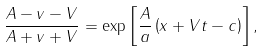Convert formula to latex. <formula><loc_0><loc_0><loc_500><loc_500>\frac { A - v - V } { A + v + V } = \exp \left [ \frac { A } { a } \left ( x + V t - c \right ) \right ] ,</formula> 